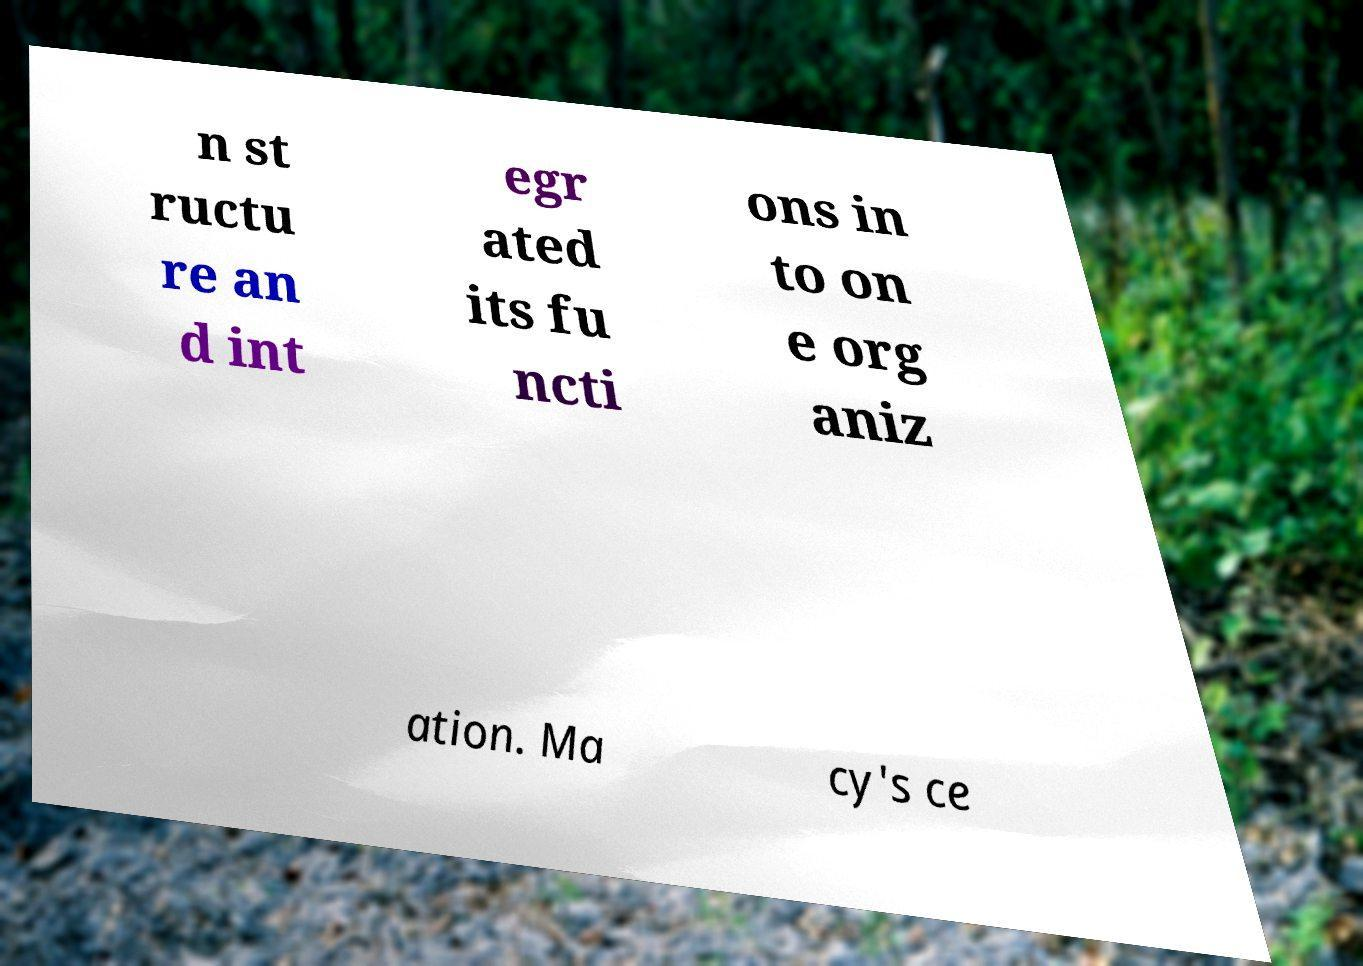Can you read and provide the text displayed in the image?This photo seems to have some interesting text. Can you extract and type it out for me? n st ructu re an d int egr ated its fu ncti ons in to on e org aniz ation. Ma cy's ce 